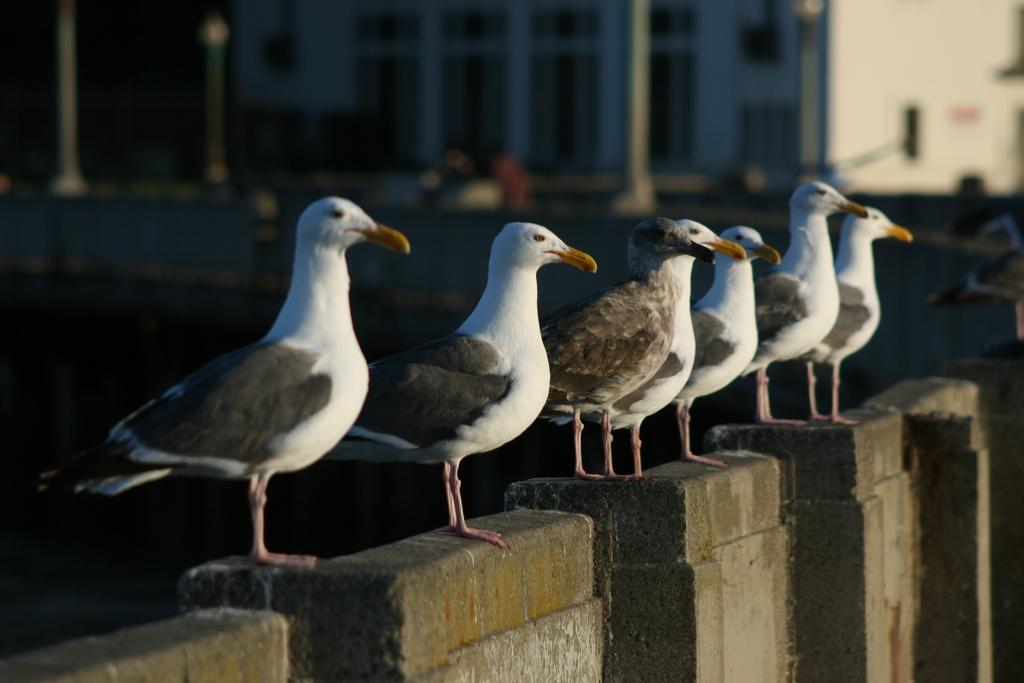What type of animals can be seen in the foreground of the image? There are birds in the foreground of the image. Where are the birds located? The birds are on a wall. What can be seen in the background of the image? There appears to be a building in the background of the image. What type of waves can be seen crashing against the wall in the image? There are no waves present in the image; it features birds on a wall and a building in the background. 